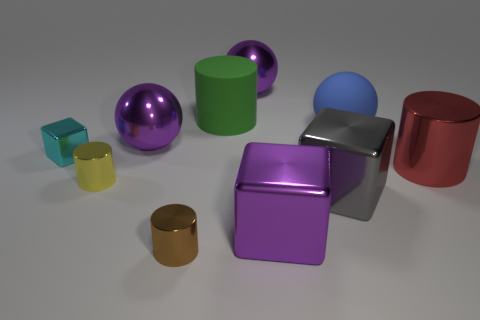Subtract all big matte cylinders. How many cylinders are left? 3 Subtract 2 cubes. How many cubes are left? 1 Subtract all gray blocks. Subtract all metallic cylinders. How many objects are left? 6 Add 7 large cubes. How many large cubes are left? 9 Add 7 big purple rubber cylinders. How many big purple rubber cylinders exist? 7 Subtract all blue spheres. How many spheres are left? 2 Subtract 1 cyan cubes. How many objects are left? 9 Subtract all blocks. How many objects are left? 7 Subtract all cyan cylinders. Subtract all brown cubes. How many cylinders are left? 4 Subtract all cyan balls. How many yellow cylinders are left? 1 